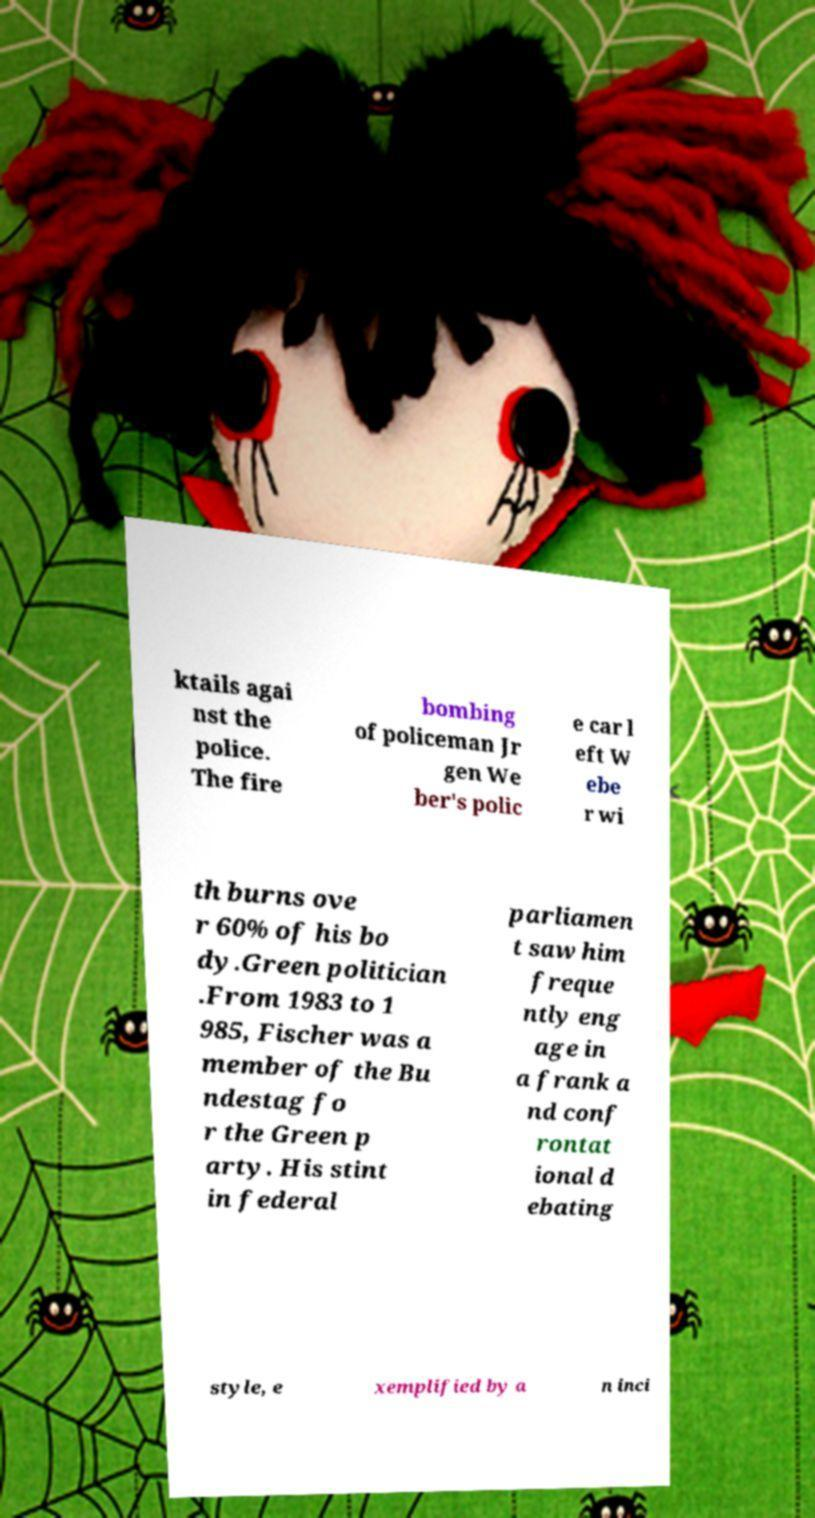Can you accurately transcribe the text from the provided image for me? ktails agai nst the police. The fire bombing of policeman Jr gen We ber's polic e car l eft W ebe r wi th burns ove r 60% of his bo dy.Green politician .From 1983 to 1 985, Fischer was a member of the Bu ndestag fo r the Green p arty. His stint in federal parliamen t saw him freque ntly eng age in a frank a nd conf rontat ional d ebating style, e xemplified by a n inci 